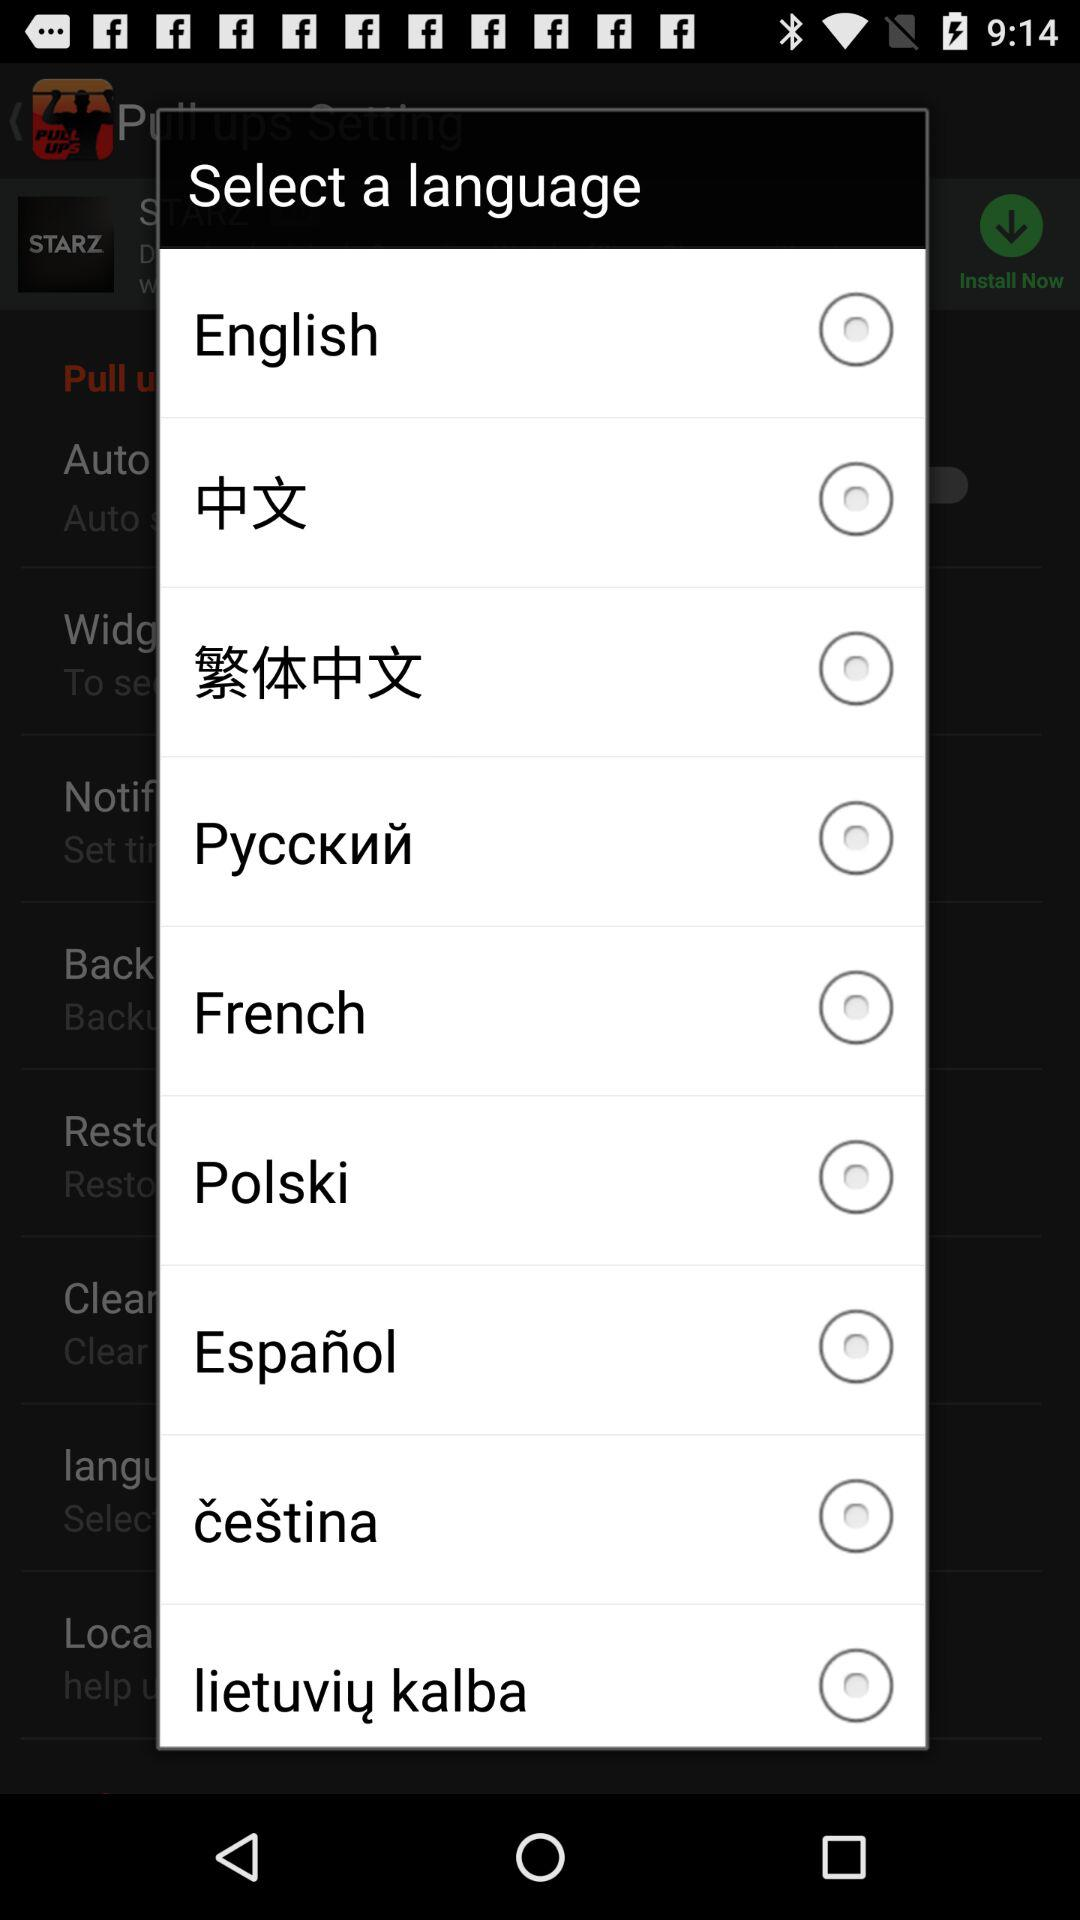What is the status of "English"? The status is "off". 